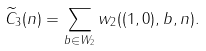<formula> <loc_0><loc_0><loc_500><loc_500>\widetilde { C } _ { 3 } ( n ) = \sum _ { b \in W _ { 2 } } w _ { 2 } ( ( 1 , 0 ) , b , n ) .</formula> 